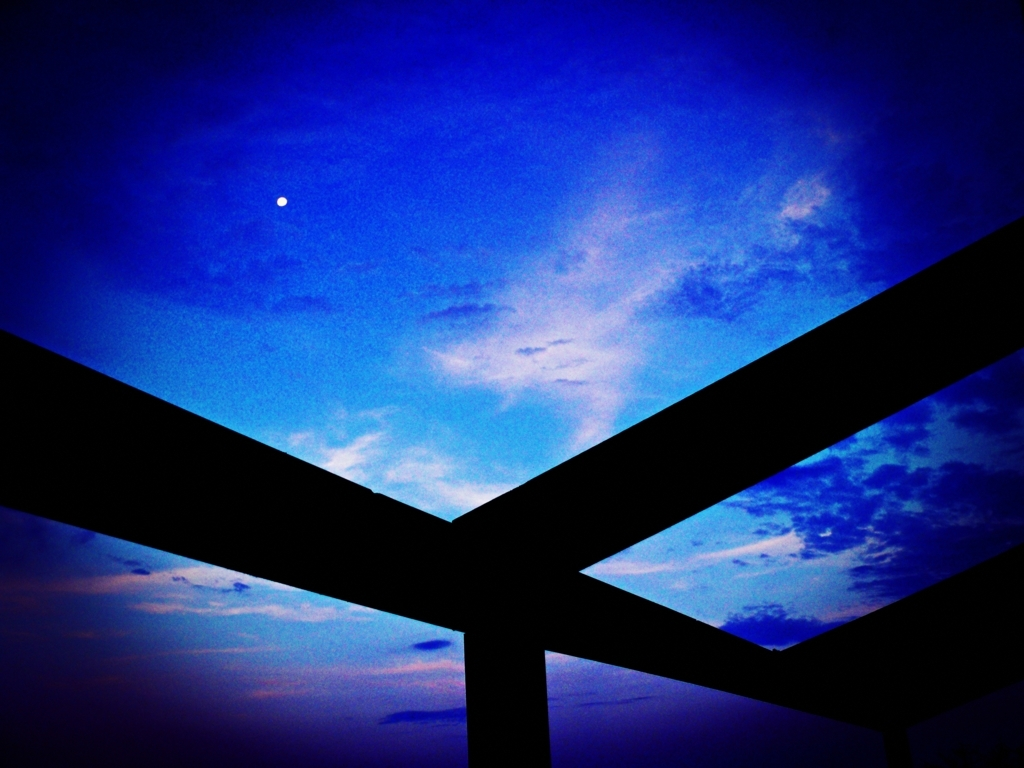What time of day does this image represent, and how can you tell? The image seems to capture the early evening, just after sunset. This is indicated by the residual light in the sky, creating soft gradients of blue and the appearance of the first visible celestial body, likely a bright star or planet, which is most visible during twilight. 